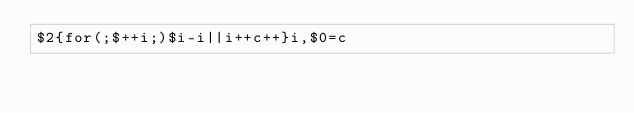Convert code to text. <code><loc_0><loc_0><loc_500><loc_500><_Awk_>$2{for(;$++i;)$i-i||i++c++}i,$0=c</code> 